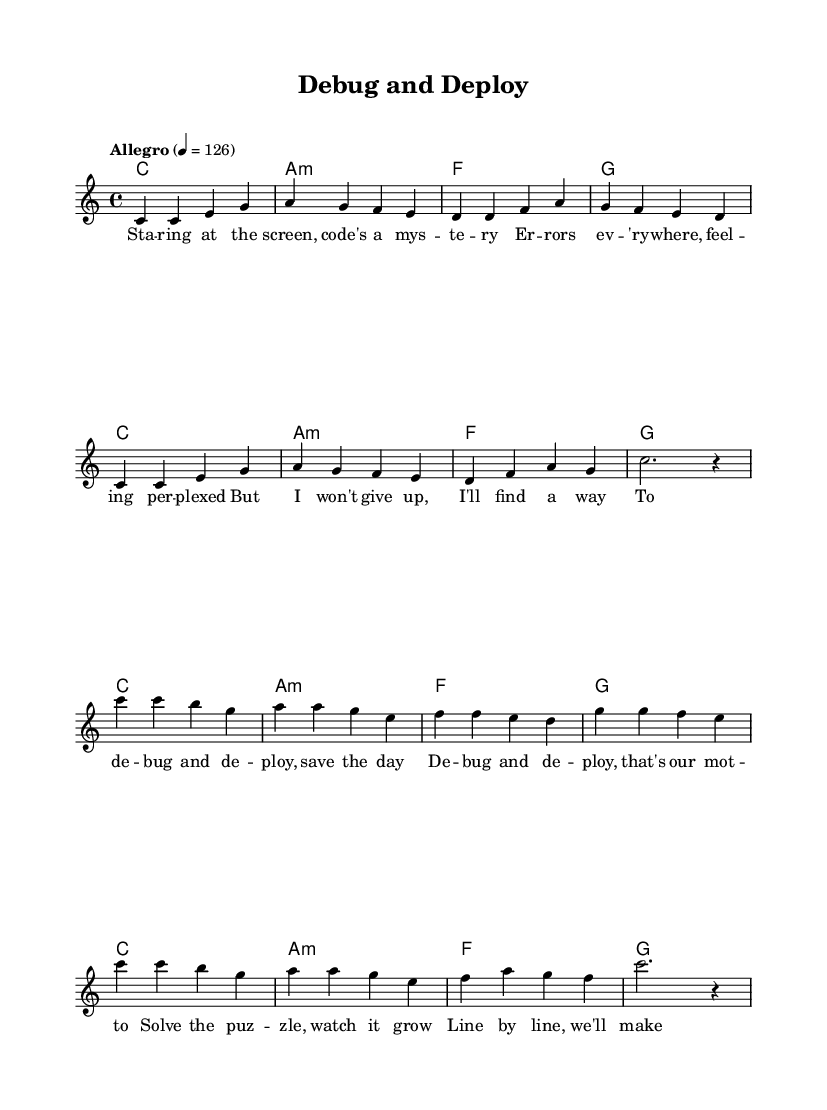What is the key signature of this music? The key signature indicated at the beginning is C major, which has no sharps or flats. This is evident from the global settings in the code.
Answer: C major What is the time signature of this music? The time signature shown in the global settings states 4/4, which means there are four beats in each measure and a quarter note gets one beat.
Answer: 4/4 What is the tempo marking for this piece? The tempo marking in the global settings states "Allegro" with a metronome marking of 126, indicating a fast tempo. This can be found in the tempo declaration in the code.
Answer: Allegro, 126 How many measures are there in the verse? The verse section consists of eight measures, which can be counted directly from the melody part in the code.
Answer: 8 What is the last note in the chorus? The last note of the chorus is an empty quarter rest followed by a half-note rest, as indicated by the closing part of the melody section in the code.
Answer: rest What is the main theme of the lyrics? The main theme revolves around problem-solving and perseverance in coding, as depicted through phrases like "debug and deploy" and "solve the puzzle." This is extracted directly from the lyrics provided in the code.
Answer: Problem-solving How does the melody relate to the lyrics? The melody and lyrics are directly correlated, with the melody being structured to fit the rhythmic pattern of the lyrics, emphasizing words that signify key actions such as "debug" and "deploy." This relation is built into the music notation by how the melody is arranged alongside the lyrics in the code.
Answer: They are correlated 